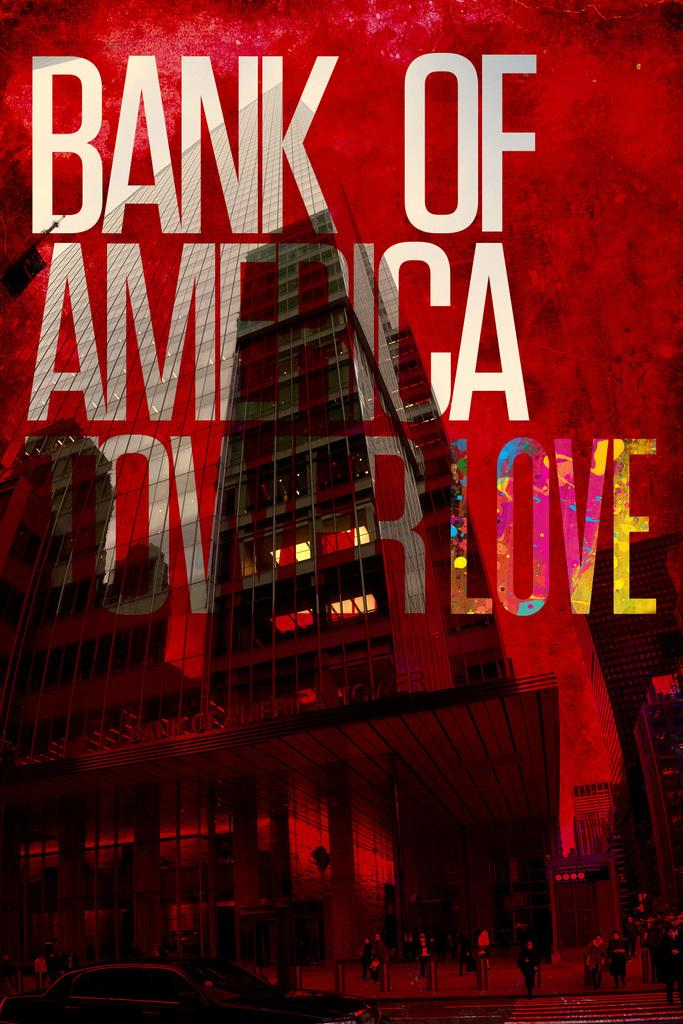What is present on the poster in the image? There is a poster in the image. What can be found on the poster besides the image? The poster contains text. What type of image is included on the poster? The poster includes an image of a building. What type of branch is growing from the building in the image? There is no branch growing from the building in the image; the poster only includes an image of a building. What event related to birth is depicted in the image? There is no event related to birth depicted in the image; the poster only includes an image of a building. 